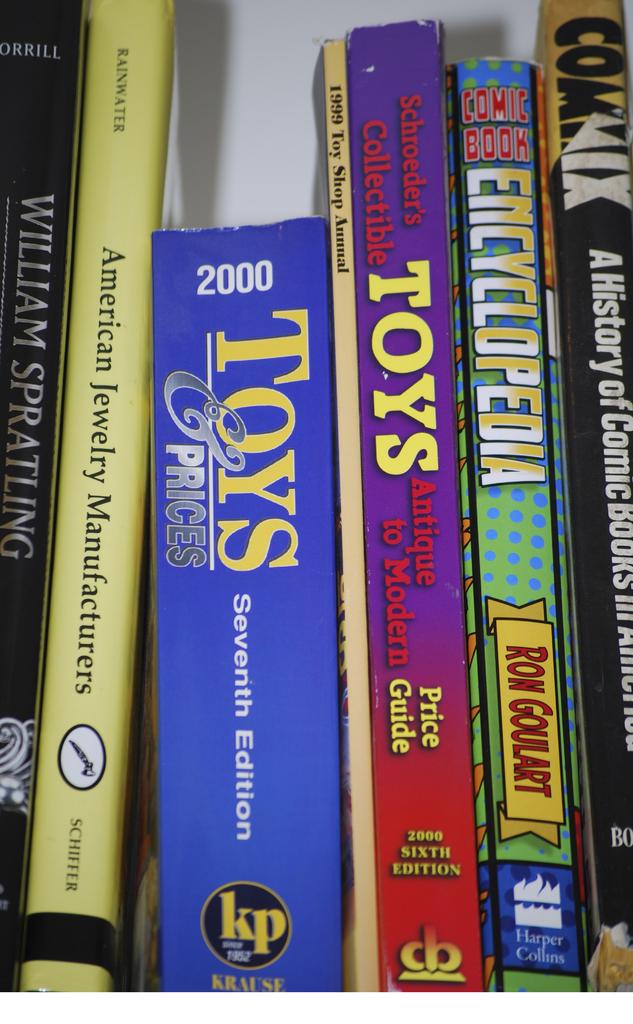What type of things does the yellow book say americans manufacture?
Offer a terse response. Jewelry. 